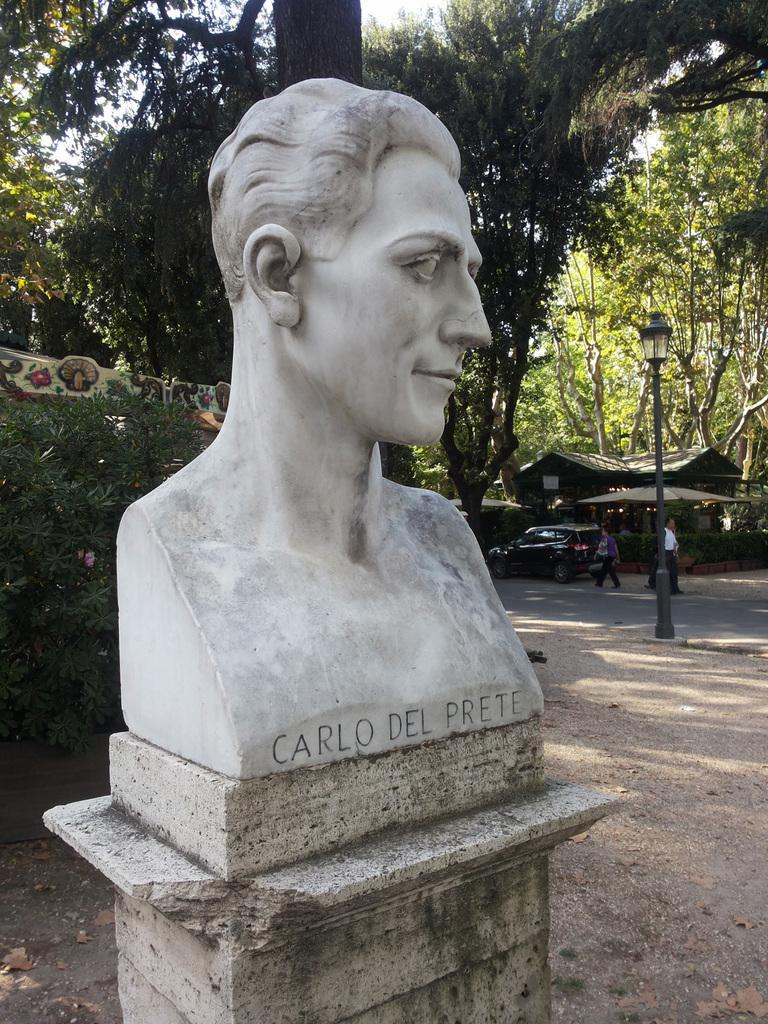How would you summarize this image in a sentence or two? This image consists of a sculpture on which there is a text. At the bottom, there is ground. In the background, there are many trees. On the right, we can see a small house along with a car on the road. 